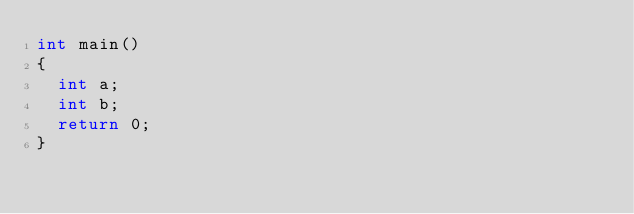<code> <loc_0><loc_0><loc_500><loc_500><_C_>int main()
{
	int a;
	int b;
	return 0;
}
</code> 